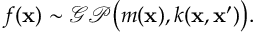Convert formula to latex. <formula><loc_0><loc_0><loc_500><loc_500>f ( x ) \sim \mathcal { G P } \left ( m ( x ) , k ( x , x ^ { \prime } ) \right ) .</formula> 